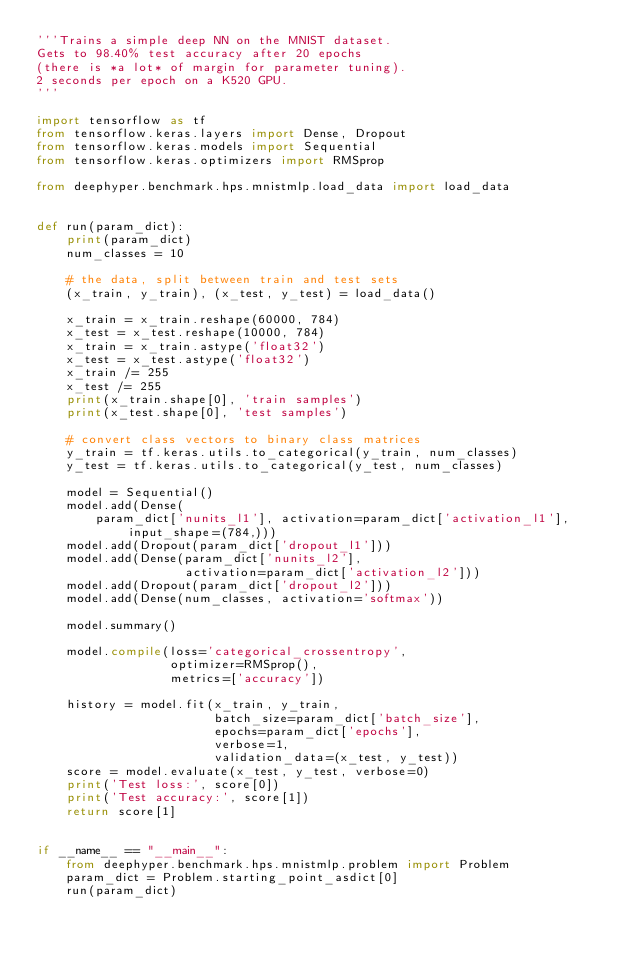Convert code to text. <code><loc_0><loc_0><loc_500><loc_500><_Python_>'''Trains a simple deep NN on the MNIST dataset.
Gets to 98.40% test accuracy after 20 epochs
(there is *a lot* of margin for parameter tuning).
2 seconds per epoch on a K520 GPU.
'''

import tensorflow as tf
from tensorflow.keras.layers import Dense, Dropout
from tensorflow.keras.models import Sequential
from tensorflow.keras.optimizers import RMSprop

from deephyper.benchmark.hps.mnistmlp.load_data import load_data


def run(param_dict):
    print(param_dict)
    num_classes = 10

    # the data, split between train and test sets
    (x_train, y_train), (x_test, y_test) = load_data()

    x_train = x_train.reshape(60000, 784)
    x_test = x_test.reshape(10000, 784)
    x_train = x_train.astype('float32')
    x_test = x_test.astype('float32')
    x_train /= 255
    x_test /= 255
    print(x_train.shape[0], 'train samples')
    print(x_test.shape[0], 'test samples')

    # convert class vectors to binary class matrices
    y_train = tf.keras.utils.to_categorical(y_train, num_classes)
    y_test = tf.keras.utils.to_categorical(y_test, num_classes)

    model = Sequential()
    model.add(Dense(
        param_dict['nunits_l1'], activation=param_dict['activation_l1'], input_shape=(784,)))
    model.add(Dropout(param_dict['dropout_l1']))
    model.add(Dense(param_dict['nunits_l2'],
                    activation=param_dict['activation_l2']))
    model.add(Dropout(param_dict['dropout_l2']))
    model.add(Dense(num_classes, activation='softmax'))

    model.summary()

    model.compile(loss='categorical_crossentropy',
                  optimizer=RMSprop(),
                  metrics=['accuracy'])

    history = model.fit(x_train, y_train,
                        batch_size=param_dict['batch_size'],
                        epochs=param_dict['epochs'],
                        verbose=1,
                        validation_data=(x_test, y_test))
    score = model.evaluate(x_test, y_test, verbose=0)
    print('Test loss:', score[0])
    print('Test accuracy:', score[1])
    return score[1]


if __name__ == "__main__":
    from deephyper.benchmark.hps.mnistmlp.problem import Problem
    param_dict = Problem.starting_point_asdict[0]
    run(param_dict)
</code> 